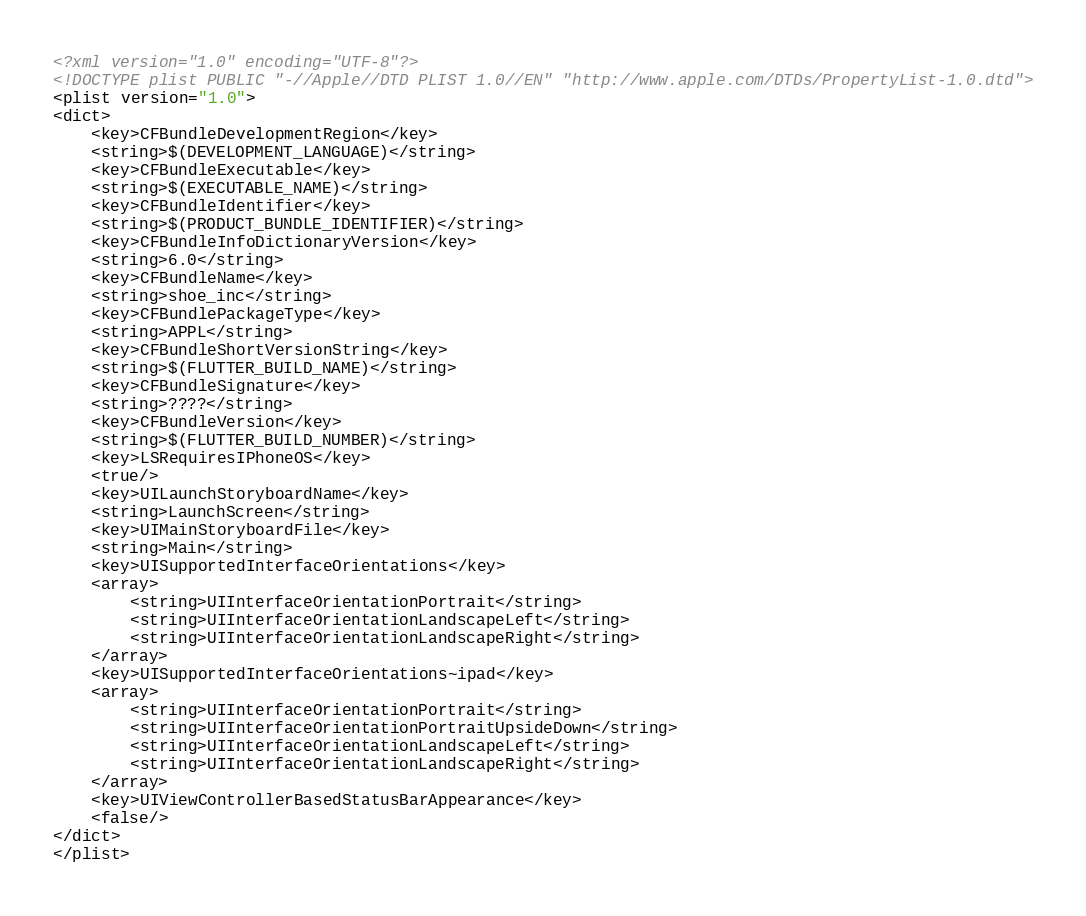Convert code to text. <code><loc_0><loc_0><loc_500><loc_500><_XML_><?xml version="1.0" encoding="UTF-8"?>
<!DOCTYPE plist PUBLIC "-//Apple//DTD PLIST 1.0//EN" "http://www.apple.com/DTDs/PropertyList-1.0.dtd">
<plist version="1.0">
<dict>
	<key>CFBundleDevelopmentRegion</key>
	<string>$(DEVELOPMENT_LANGUAGE)</string>
	<key>CFBundleExecutable</key>
	<string>$(EXECUTABLE_NAME)</string>
	<key>CFBundleIdentifier</key>
	<string>$(PRODUCT_BUNDLE_IDENTIFIER)</string>
	<key>CFBundleInfoDictionaryVersion</key>
	<string>6.0</string>
	<key>CFBundleName</key>
	<string>shoe_inc</string>
	<key>CFBundlePackageType</key>
	<string>APPL</string>
	<key>CFBundleShortVersionString</key>
	<string>$(FLUTTER_BUILD_NAME)</string>
	<key>CFBundleSignature</key>
	<string>????</string>
	<key>CFBundleVersion</key>
	<string>$(FLUTTER_BUILD_NUMBER)</string>
	<key>LSRequiresIPhoneOS</key>
	<true/>
	<key>UILaunchStoryboardName</key>
	<string>LaunchScreen</string>
	<key>UIMainStoryboardFile</key>
	<string>Main</string>
	<key>UISupportedInterfaceOrientations</key>
	<array>
		<string>UIInterfaceOrientationPortrait</string>
		<string>UIInterfaceOrientationLandscapeLeft</string>
		<string>UIInterfaceOrientationLandscapeRight</string>
	</array>
	<key>UISupportedInterfaceOrientations~ipad</key>
	<array>
		<string>UIInterfaceOrientationPortrait</string>
		<string>UIInterfaceOrientationPortraitUpsideDown</string>
		<string>UIInterfaceOrientationLandscapeLeft</string>
		<string>UIInterfaceOrientationLandscapeRight</string>
	</array>
	<key>UIViewControllerBasedStatusBarAppearance</key>
	<false/>
</dict>
</plist>
</code> 